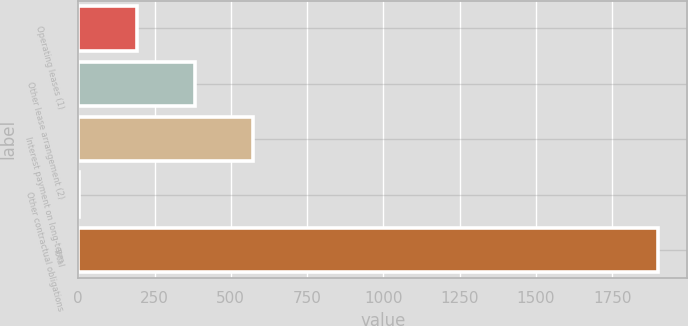<chart> <loc_0><loc_0><loc_500><loc_500><bar_chart><fcel>Operating leases (1)<fcel>Other lease arrangement (2)<fcel>Interest payment on long-term<fcel>Other contractual obligations<fcel>Total<nl><fcel>192.69<fcel>382.48<fcel>572.27<fcel>2.9<fcel>1900.8<nl></chart> 